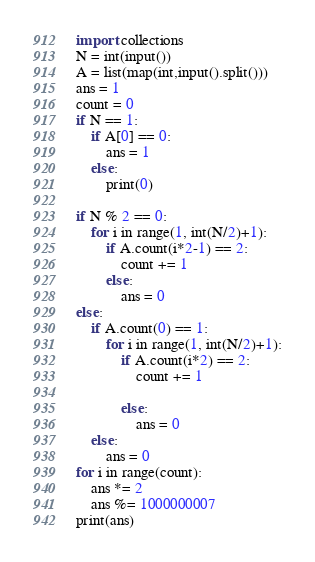Convert code to text. <code><loc_0><loc_0><loc_500><loc_500><_Python_>import collections
N = int(input())
A = list(map(int,input().split()))
ans = 1
count = 0
if N == 1:
    if A[0] == 0:
        ans = 1
    else:
        print(0)

if N % 2 == 0:
    for i in range(1, int(N/2)+1):
        if A.count(i*2-1) == 2:
            count += 1
        else:
            ans = 0
else:
    if A.count(0) == 1:
        for i in range(1, int(N/2)+1):
            if A.count(i*2) == 2:
                count += 1

            else:
                ans = 0
    else:
        ans = 0
for i in range(count):
    ans *= 2
    ans %= 1000000007
print(ans)
</code> 